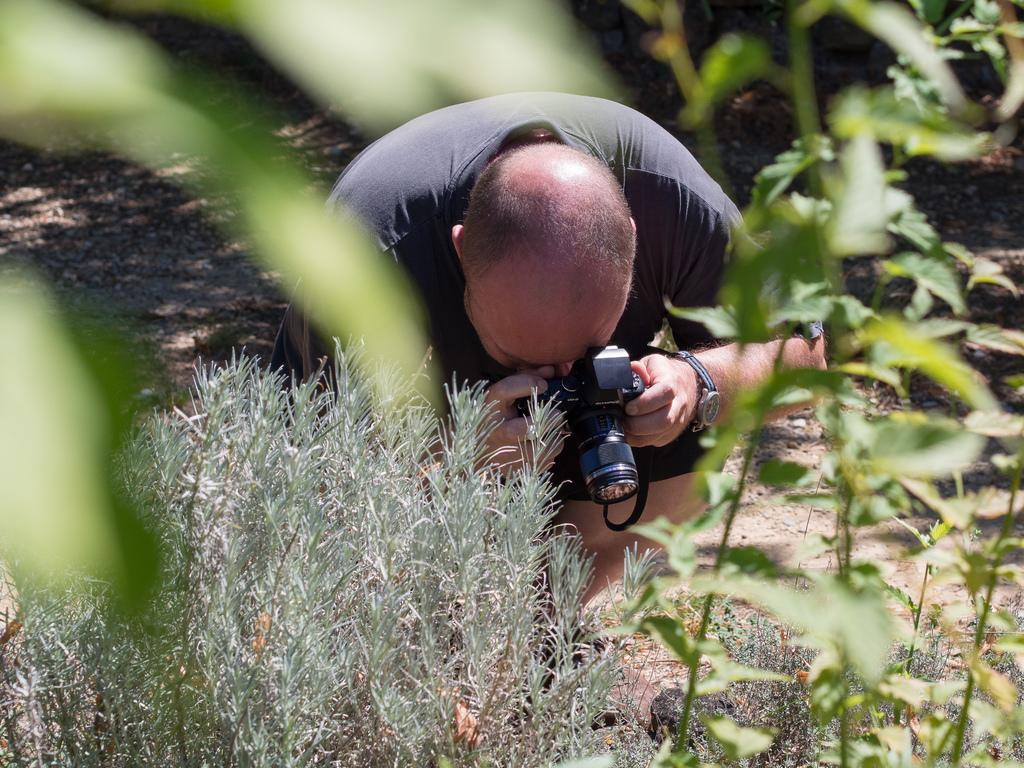What is the man in the image doing? The man is taking a picture. What is the man wearing in the image? The man is wearing a black t-shirt. What is the man holding in his hand in the image? The man is holding a camera in his hand. Where is the man sitting in the image? The man is sitting on the ground. What can be seen in front of the man in the image? There are plants in front of the man. What type of whip is the man using to take a picture in the image? There is no whip present in the image; the man is using a camera to take a picture. 